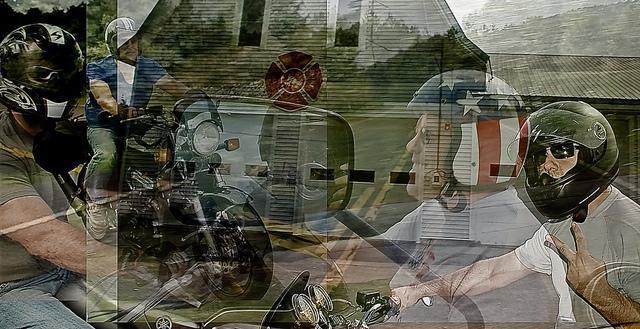How many motorcycles?
Give a very brief answer. 2. How many people are in the photo?
Give a very brief answer. 4. How many motorcycles can be seen?
Give a very brief answer. 3. 